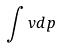Convert formula to latex. <formula><loc_0><loc_0><loc_500><loc_500>\int v d p</formula> 